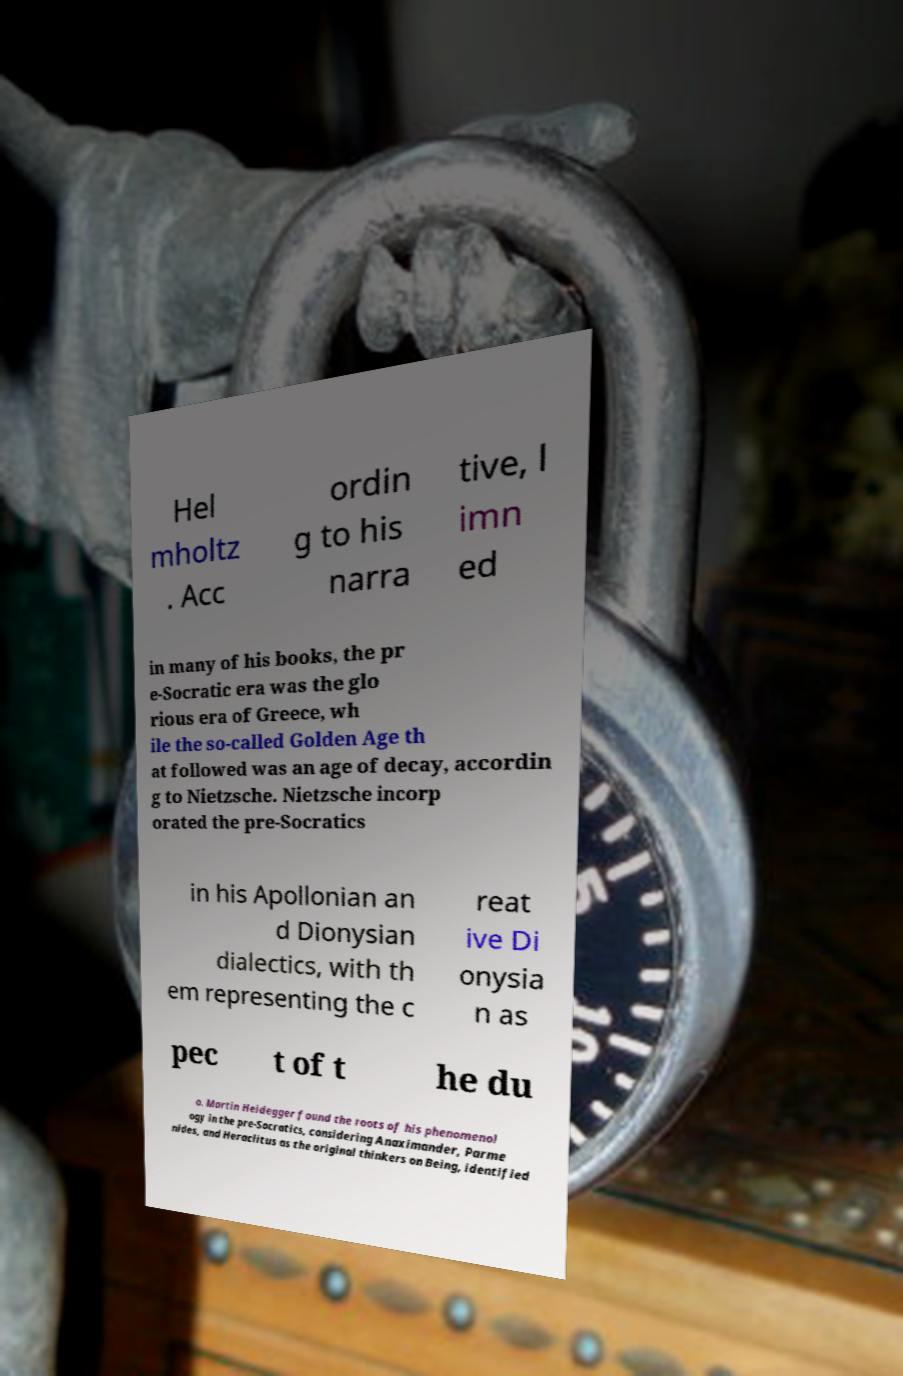Can you read and provide the text displayed in the image?This photo seems to have some interesting text. Can you extract and type it out for me? Hel mholtz . Acc ordin g to his narra tive, l imn ed in many of his books, the pr e-Socratic era was the glo rious era of Greece, wh ile the so-called Golden Age th at followed was an age of decay, accordin g to Nietzsche. Nietzsche incorp orated the pre-Socratics in his Apollonian an d Dionysian dialectics, with th em representing the c reat ive Di onysia n as pec t of t he du o. Martin Heidegger found the roots of his phenomenol ogy in the pre-Socratics, considering Anaximander, Parme nides, and Heraclitus as the original thinkers on Being, identified 